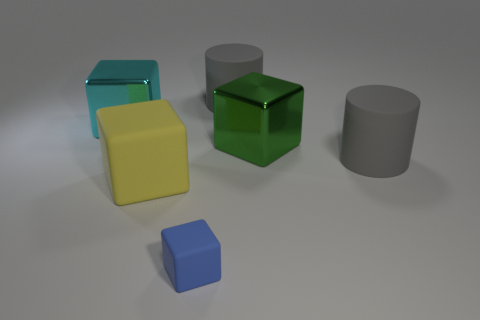There is a block to the right of the small thing; how many big metallic blocks are behind it?
Your response must be concise. 1. Are there any tiny matte things of the same shape as the big cyan metal thing?
Your answer should be compact. Yes. What color is the big metallic cube right of the large gray matte cylinder behind the big cyan thing?
Keep it short and to the point. Green. Is the number of large matte cylinders greater than the number of small red rubber cylinders?
Ensure brevity in your answer.  Yes. What number of purple metal things have the same size as the yellow cube?
Keep it short and to the point. 0. Are the large green object and the big cube that is on the left side of the yellow rubber object made of the same material?
Ensure brevity in your answer.  Yes. Are there fewer big purple metal cubes than blue objects?
Offer a terse response. Yes. Is there any other thing that is the same color as the small rubber block?
Make the answer very short. No. There is a large cyan object that is made of the same material as the green object; what shape is it?
Provide a succinct answer. Cube. There is a metallic object that is to the left of the thing that is in front of the big yellow block; how many gray rubber cylinders are in front of it?
Keep it short and to the point. 1. 